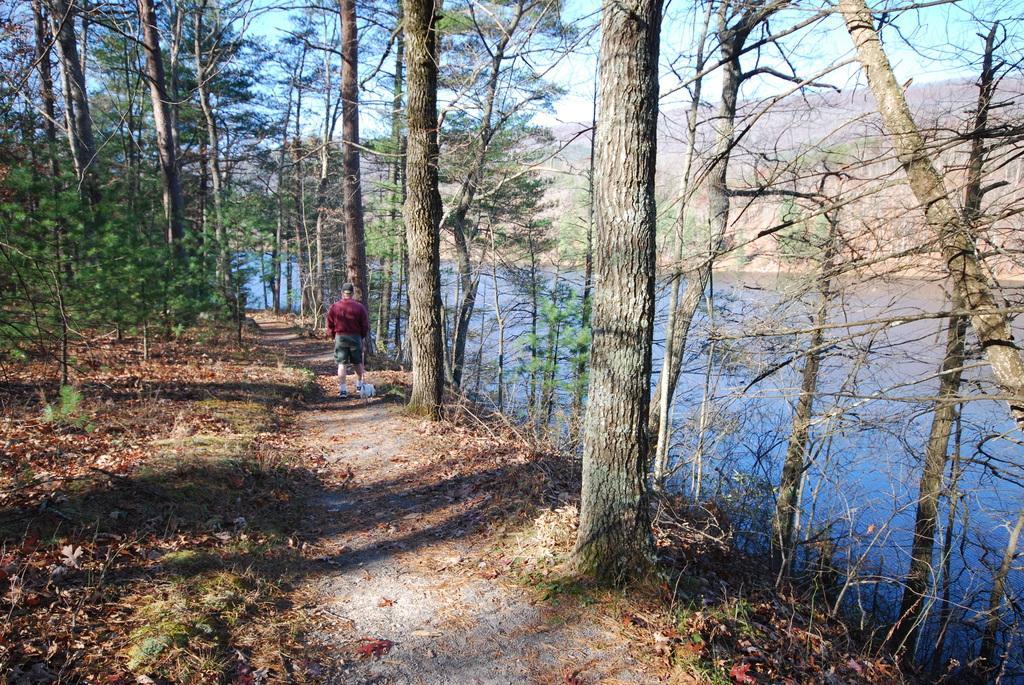Could you give a brief overview of what you see in this image? This is the man standing. I think this is a pathway. These are the trees. I think these are the water. In the background, that looks like a hill. 